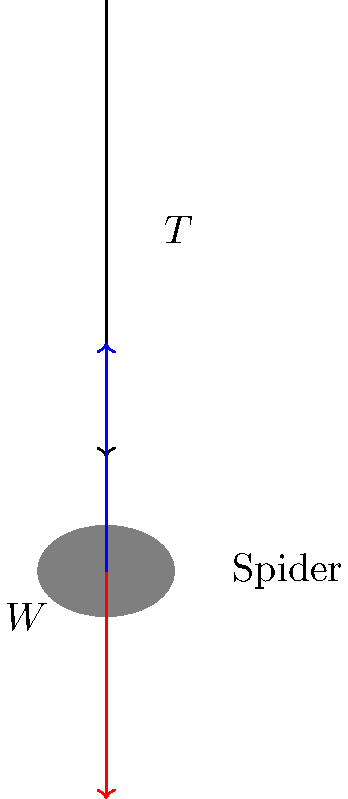A spider of mass $m$ is hanging motionless from a silk thread. Consider the forces acting on the spider. What is the tension $T$ in the silk thread in terms of the spider's weight $W$? To solve this problem, let's follow these steps:

1. Identify the forces acting on the spider:
   - Tension ($T$) in the silk thread (upward)
   - Weight ($W$) of the spider (downward)

2. Recall that weight is related to mass by $W = mg$, where $g$ is the acceleration due to gravity.

3. Since the spider is motionless, it is in equilibrium. This means the sum of all forces acting on the spider must be zero.

4. Apply Newton's Second Law in the vertical direction:
   $$\sum F_y = T - W = 0$$

5. Rearrange the equation to solve for $T$:
   $$T = W$$

6. Remember that $W = mg$, so we can also express this as:
   $$T = mg$$

Therefore, the tension in the silk thread is equal to the weight of the spider.
Answer: $T = W$ 